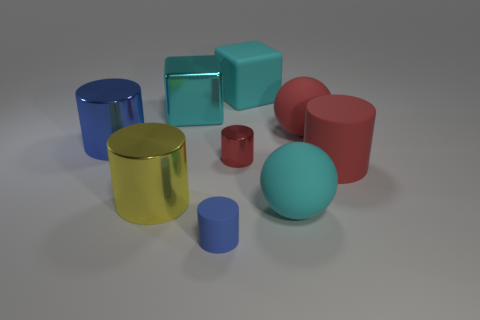What is the size of the other blue rubber thing that is the same shape as the large blue thing?
Make the answer very short. Small. There is a blue object that is behind the large matte cylinder; is its shape the same as the blue matte object?
Your response must be concise. Yes. What shape is the big red rubber object that is behind the blue thing behind the tiny blue cylinder?
Your response must be concise. Sphere. What is the color of the small metallic thing that is the same shape as the big blue metallic thing?
Give a very brief answer. Red. Do the tiny rubber cylinder and the metal cylinder behind the small metallic cylinder have the same color?
Make the answer very short. Yes. The metallic object that is in front of the red ball and on the right side of the yellow metal cylinder has what shape?
Ensure brevity in your answer.  Cylinder. Is the number of cyan matte cubes less than the number of cyan matte things?
Keep it short and to the point. Yes. Are there any large cylinders?
Offer a terse response. Yes. How many other objects are there of the same size as the cyan ball?
Your response must be concise. 6. Do the big yellow object and the blue thing to the left of the small blue cylinder have the same material?
Your answer should be compact. Yes. 